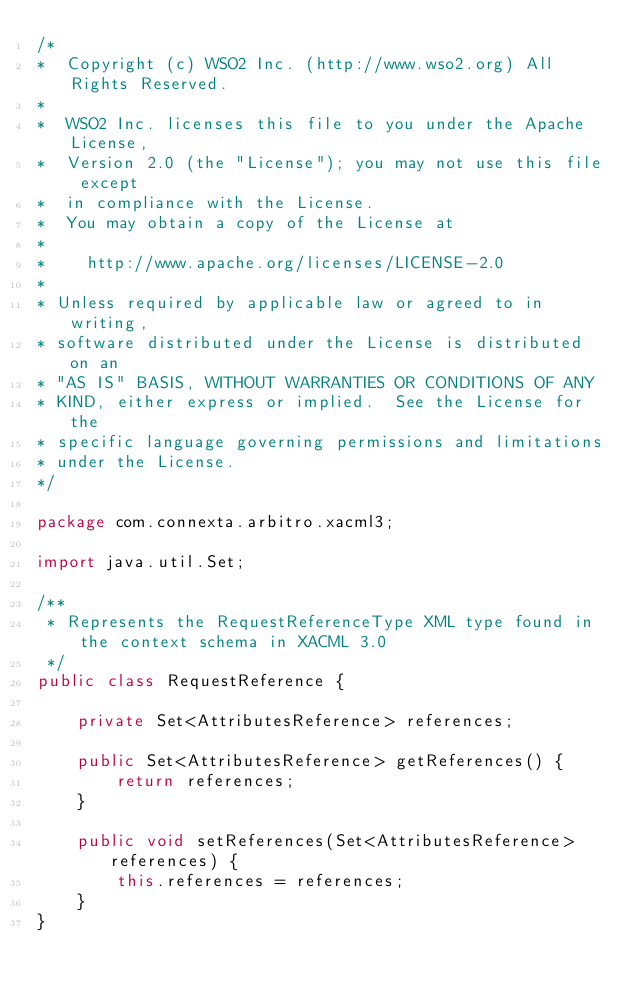Convert code to text. <code><loc_0><loc_0><loc_500><loc_500><_Java_>/*
*  Copyright (c) WSO2 Inc. (http://www.wso2.org) All Rights Reserved.
*
*  WSO2 Inc. licenses this file to you under the Apache License,
*  Version 2.0 (the "License"); you may not use this file except
*  in compliance with the License.
*  You may obtain a copy of the License at
*
*    http://www.apache.org/licenses/LICENSE-2.0
*
* Unless required by applicable law or agreed to in writing,
* software distributed under the License is distributed on an
* "AS IS" BASIS, WITHOUT WARRANTIES OR CONDITIONS OF ANY
* KIND, either express or implied.  See the License for the
* specific language governing permissions and limitations
* under the License.
*/

package com.connexta.arbitro.xacml3;

import java.util.Set;

/**
 * Represents the RequestReferenceType XML type found in the context schema in XACML 3.0 
 */
public class RequestReference {

    private Set<AttributesReference> references;

    public Set<AttributesReference> getReferences() {
        return references;
    }

    public void setReferences(Set<AttributesReference> references) {
        this.references = references;
    }
}
</code> 